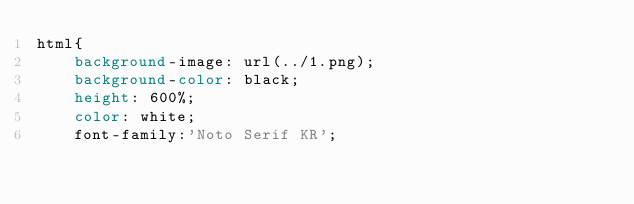<code> <loc_0><loc_0><loc_500><loc_500><_CSS_>html{
    background-image: url(../1.png);
    background-color: black;
    height: 600%;
    color: white;
    font-family:'Noto Serif KR';</code> 